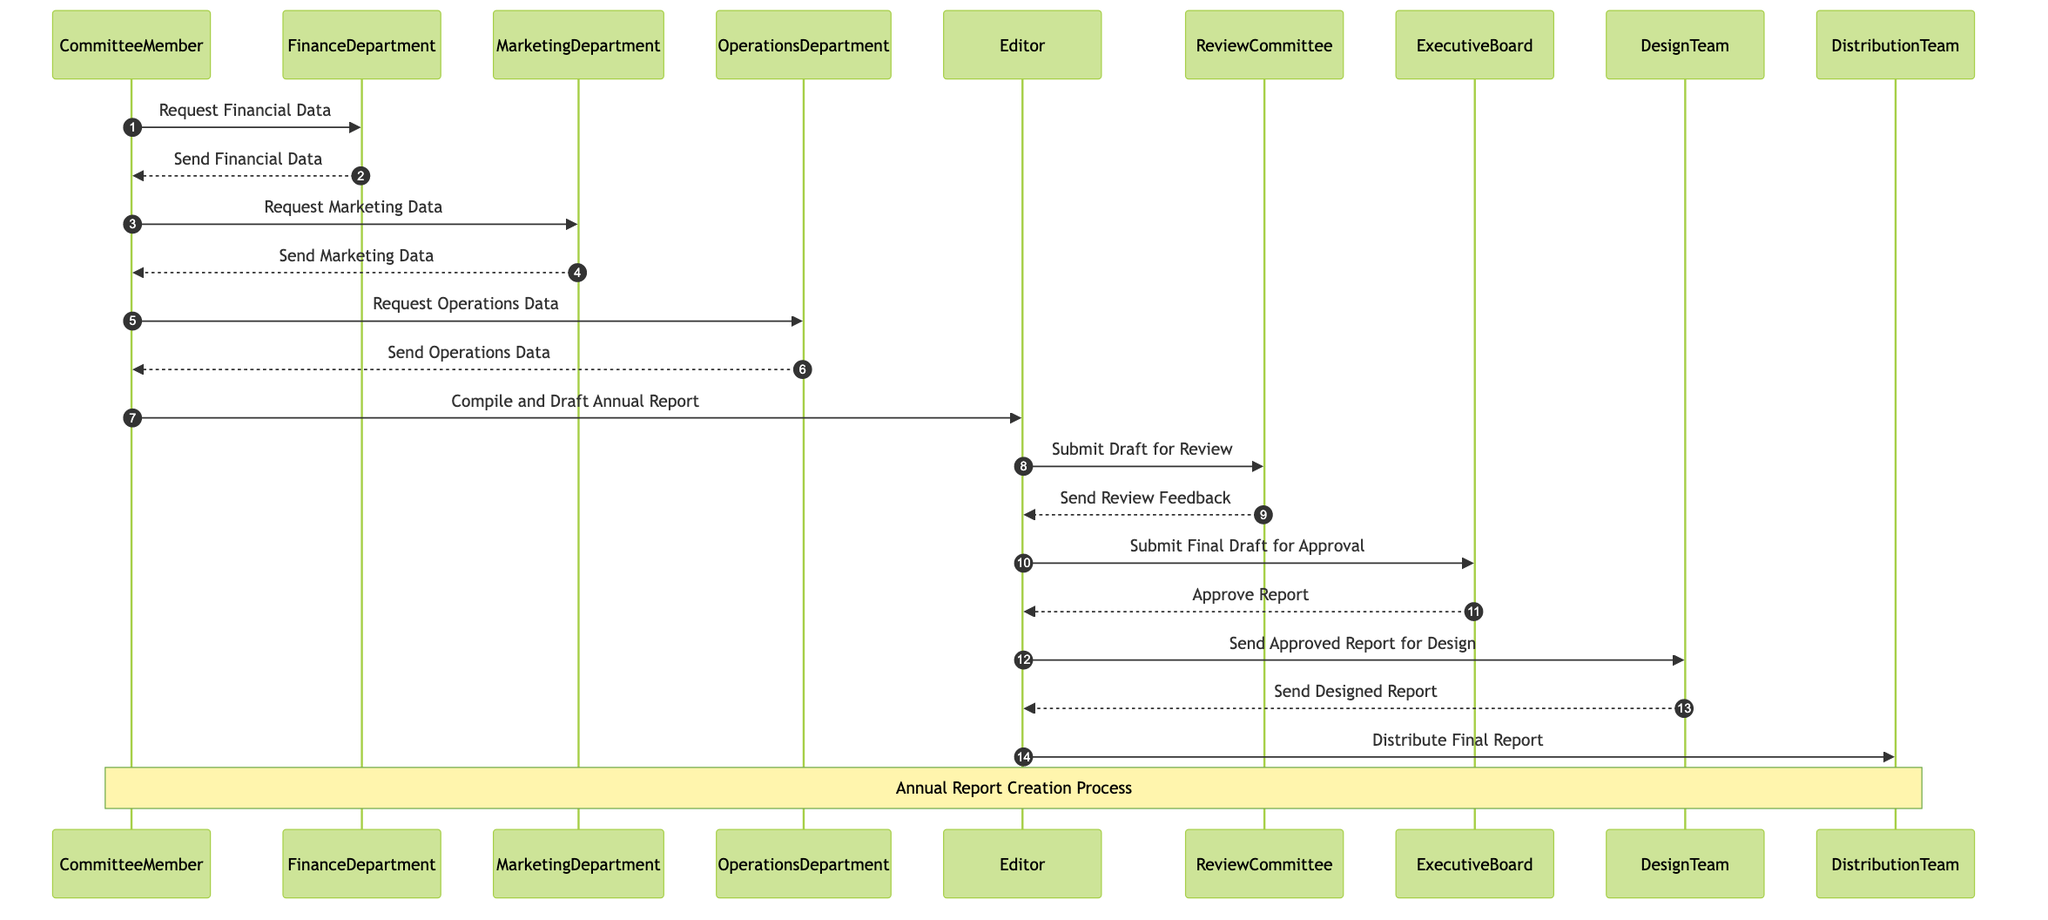What is the role of the CommitteeMember? The CommitteeMember acts as the Initiator, starting the sequence of requests for data and overseeing the process to create the annual report.
Answer: Initiator How many data providers are involved in the process? There are three data providers (FinanceDepartment, MarketingDepartment, and OperationsDepartment) that provide necessary data for the report.
Answer: 3 Who submits the draft for review? The Editor is responsible for submitting the draft to the ReviewCommittee for feedback after compiling the annual report.
Answer: Editor Which team designs the approved report? The DesignTeam is tasked with designing the report after the Editor sends them the approved draft.
Answer: DesignTeam What is the final step before the report distribution? The last step before distribution involves the Editor distributing the final report to the intended recipients after completing all previous steps, including design.
Answer: Distribute Final Report What feedback does the ReviewCommittee send to the Editor? The ReviewCommittee sends review feedback to the Editor after reviewing the draft submitted for their input.
Answer: Send Review Feedback How many messages are exchanged in total in this sequence? By counting each unique communication exchange in the diagram, there are eleven messages passed between participants throughout the process.
Answer: 11 What does the ExecutiveBoard do in the sequence? The ExecutiveBoard is involved in the process to approve the final draft submitted by the Editor before it is sent for design.
Answer: Approve Report 